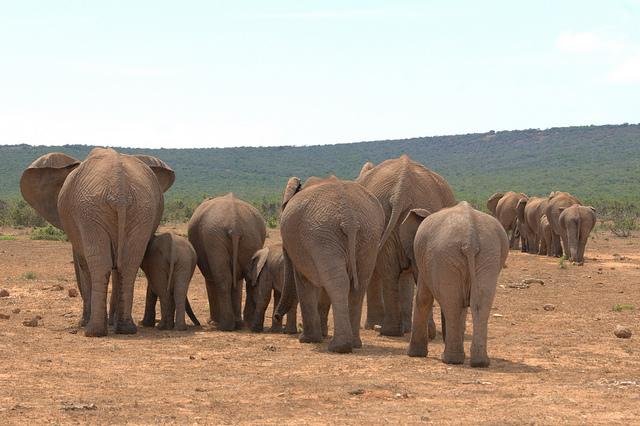Is this a herd?
Write a very short answer. Yes. Where are the baby elephants?
Quick response, please. In middle. Is it being guarded?
Short answer required. No. Could this be in the wild?
Give a very brief answer. Yes. 